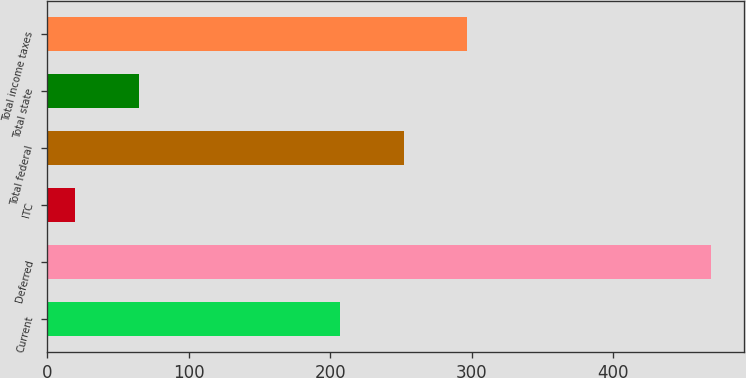Convert chart to OTSL. <chart><loc_0><loc_0><loc_500><loc_500><bar_chart><fcel>Current<fcel>Deferred<fcel>ITC<fcel>Total federal<fcel>Total state<fcel>Total income taxes<nl><fcel>207<fcel>469<fcel>20<fcel>251.9<fcel>64.9<fcel>296.8<nl></chart> 